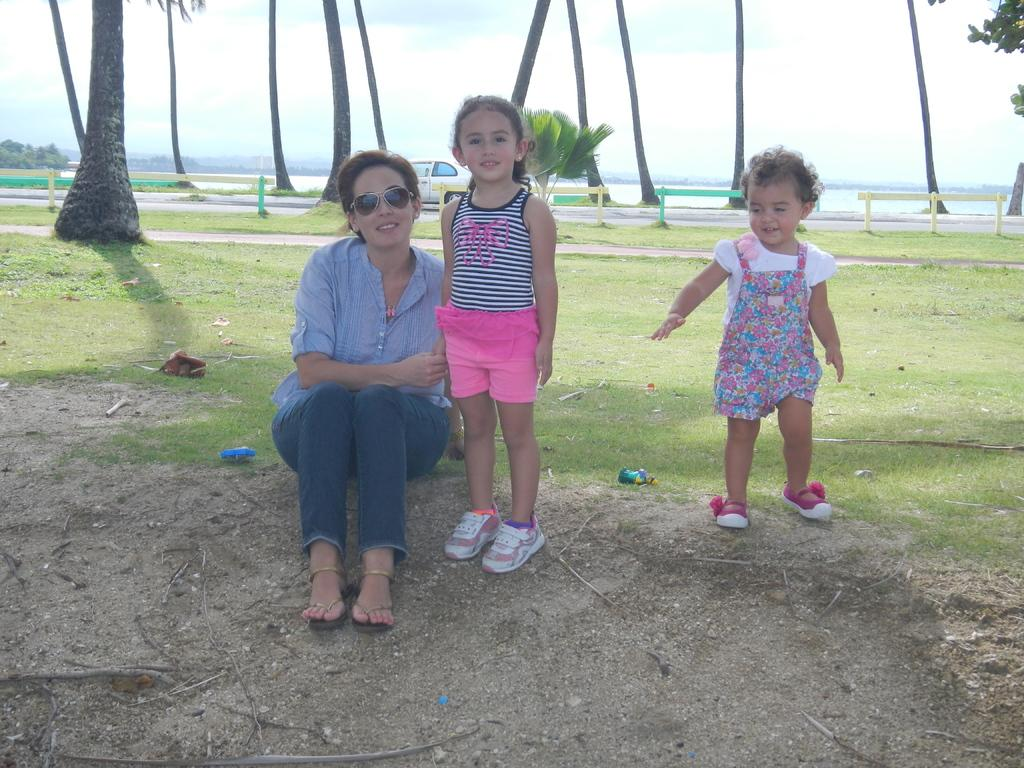What is the woman doing in the image? There is a woman sitting in the image. What are the two kids doing in the image? There are two kids standing in the image. What can be seen in the background of the image? There are tree trunks and a car on the road visible in the background of the image. What type of vegetation is present in the image? There is grass in the image. How many spiders are crawling on the woman's hair in the image? There are no spiders visible in the image, so it is not possible to determine how many might be on the woman's hair. 